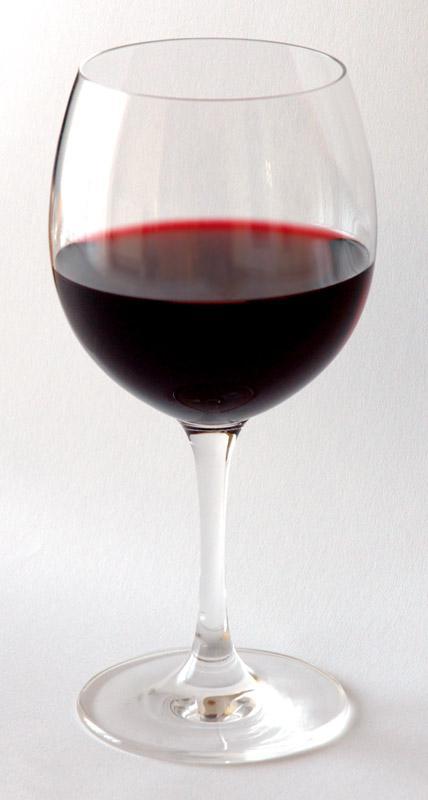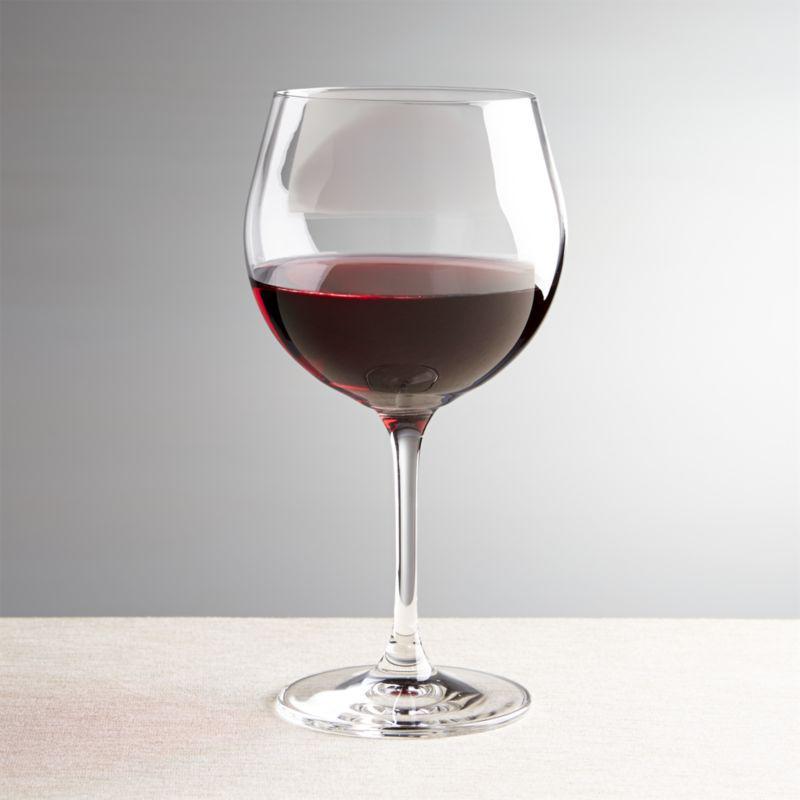The first image is the image on the left, the second image is the image on the right. Assess this claim about the two images: "The reflection of the wineglass can be seen in the surface upon which it is sitting in the image on the left.". Correct or not? Answer yes or no. No. 